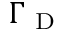Convert formula to latex. <formula><loc_0><loc_0><loc_500><loc_500>\Gamma _ { D }</formula> 